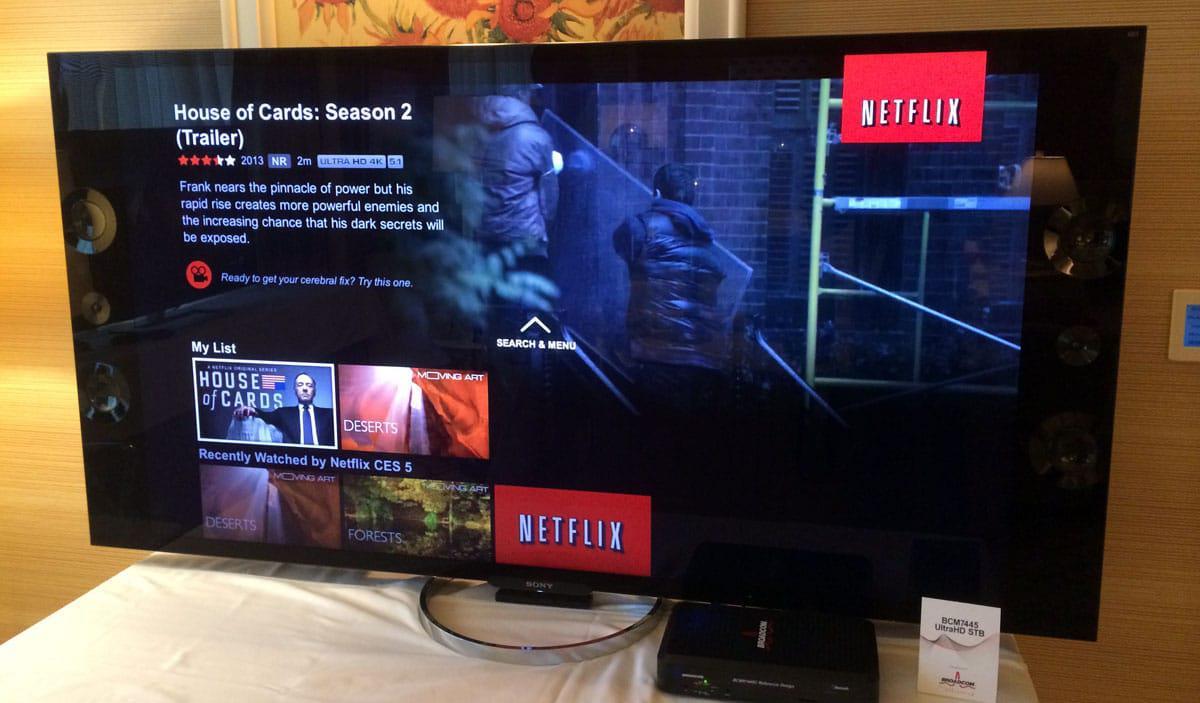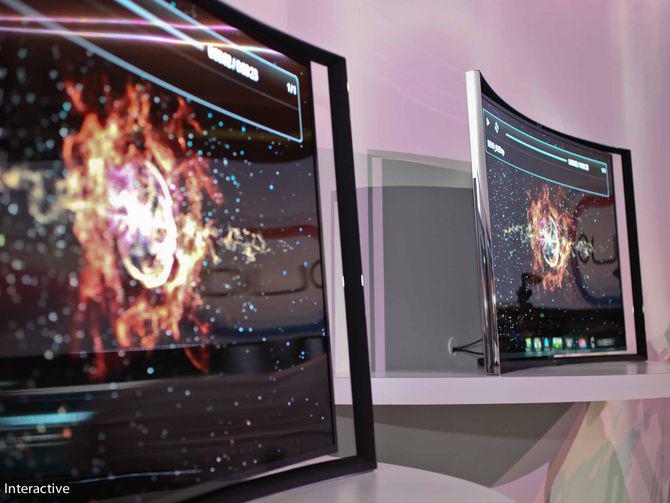The first image is the image on the left, the second image is the image on the right. Evaluate the accuracy of this statement regarding the images: "The right image contains more screened devices than the left image.". Is it true? Answer yes or no. Yes. The first image is the image on the left, the second image is the image on the right. Assess this claim about the two images: "One of the televisions is in front of a bricked wall.". Correct or not? Answer yes or no. No. 